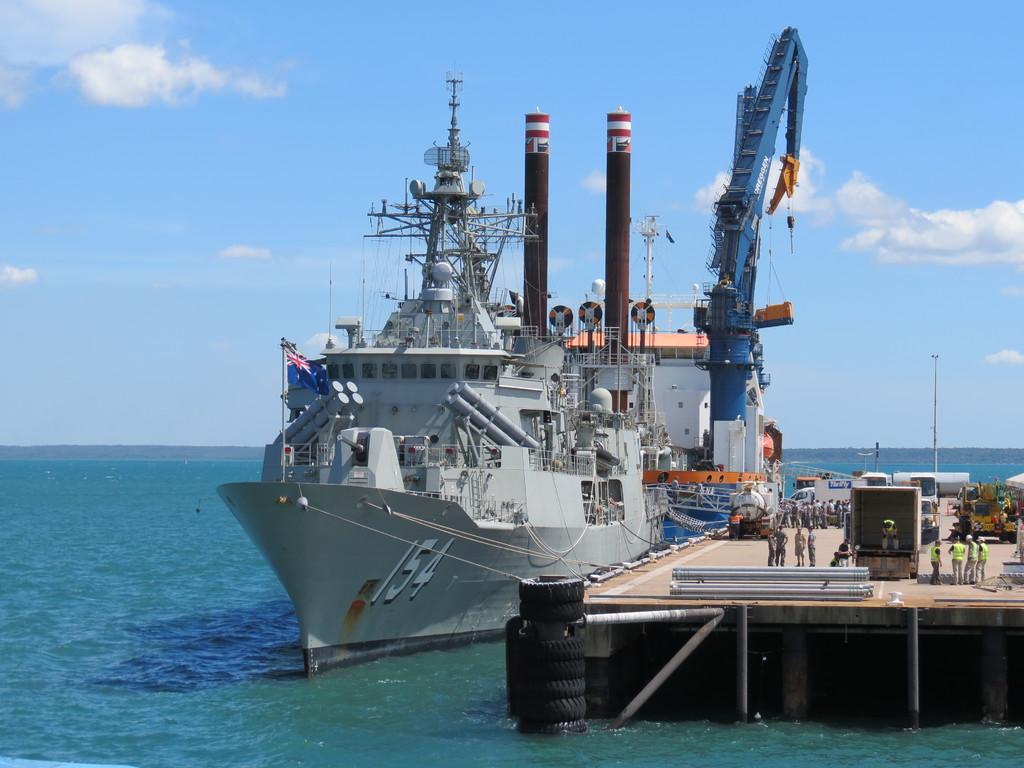In one or two sentences, can you explain what this image depicts? In this image there is the sky truncated towards the top of the image, there are clouds in the sky, there is the sea truncated, there is a ship on the sea, there is a flag, there are tires, there are persons standing, there are objects truncated towards the right of the image, there are objects on the wooden surface, there are poles. 